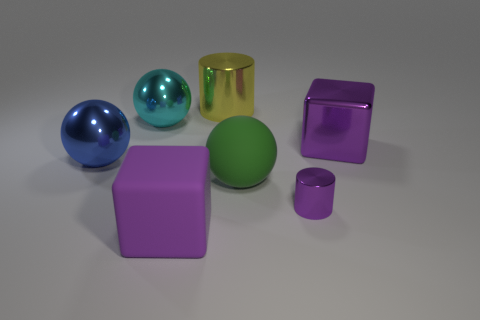Add 2 large blocks. How many objects exist? 9 Subtract all large green spheres. How many spheres are left? 2 Subtract all spheres. How many objects are left? 4 Add 1 tiny metallic objects. How many tiny metallic objects exist? 2 Subtract 1 cyan balls. How many objects are left? 6 Subtract all yellow cylinders. Subtract all brown cubes. How many cylinders are left? 1 Subtract all tiny cubes. Subtract all small metal cylinders. How many objects are left? 6 Add 5 yellow cylinders. How many yellow cylinders are left? 6 